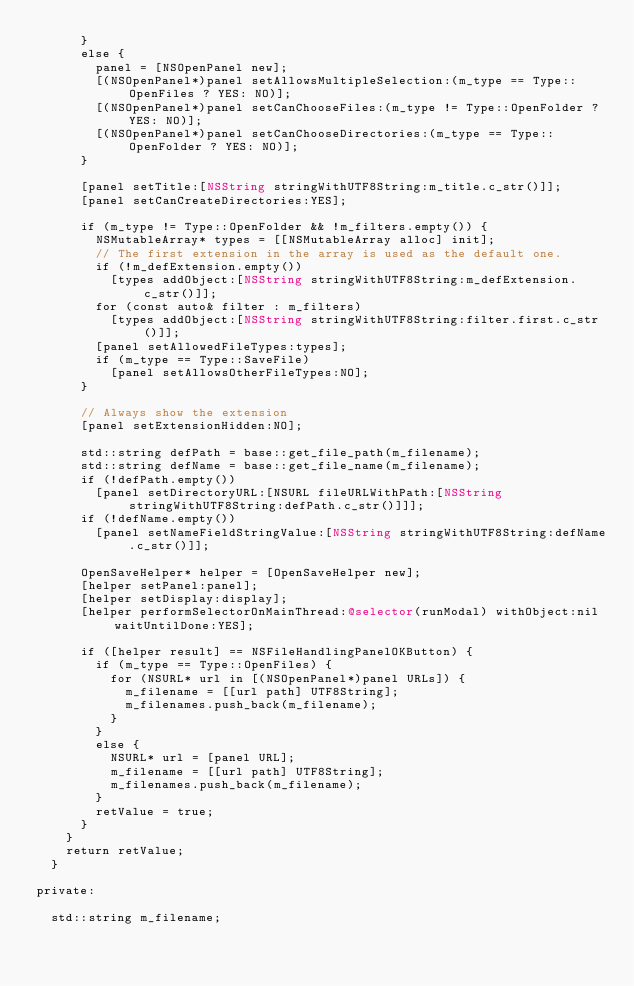Convert code to text. <code><loc_0><loc_0><loc_500><loc_500><_ObjectiveC_>      }
      else {
        panel = [NSOpenPanel new];
        [(NSOpenPanel*)panel setAllowsMultipleSelection:(m_type == Type::OpenFiles ? YES: NO)];
        [(NSOpenPanel*)panel setCanChooseFiles:(m_type != Type::OpenFolder ? YES: NO)];
        [(NSOpenPanel*)panel setCanChooseDirectories:(m_type == Type::OpenFolder ? YES: NO)];
      }

      [panel setTitle:[NSString stringWithUTF8String:m_title.c_str()]];
      [panel setCanCreateDirectories:YES];

      if (m_type != Type::OpenFolder && !m_filters.empty()) {
        NSMutableArray* types = [[NSMutableArray alloc] init];
        // The first extension in the array is used as the default one.
        if (!m_defExtension.empty())
          [types addObject:[NSString stringWithUTF8String:m_defExtension.c_str()]];
        for (const auto& filter : m_filters)
          [types addObject:[NSString stringWithUTF8String:filter.first.c_str()]];
        [panel setAllowedFileTypes:types];
        if (m_type == Type::SaveFile)
          [panel setAllowsOtherFileTypes:NO];
      }

      // Always show the extension
      [panel setExtensionHidden:NO];

      std::string defPath = base::get_file_path(m_filename);
      std::string defName = base::get_file_name(m_filename);
      if (!defPath.empty())
        [panel setDirectoryURL:[NSURL fileURLWithPath:[NSString stringWithUTF8String:defPath.c_str()]]];
      if (!defName.empty())
        [panel setNameFieldStringValue:[NSString stringWithUTF8String:defName.c_str()]];

      OpenSaveHelper* helper = [OpenSaveHelper new];
      [helper setPanel:panel];
      [helper setDisplay:display];
      [helper performSelectorOnMainThread:@selector(runModal) withObject:nil waitUntilDone:YES];

      if ([helper result] == NSFileHandlingPanelOKButton) {
        if (m_type == Type::OpenFiles) {
          for (NSURL* url in [(NSOpenPanel*)panel URLs]) {
            m_filename = [[url path] UTF8String];
            m_filenames.push_back(m_filename);
          }
        }
        else {
          NSURL* url = [panel URL];
          m_filename = [[url path] UTF8String];
          m_filenames.push_back(m_filename);
        }
        retValue = true;
      }
    }
    return retValue;
  }

private:

  std::string m_filename;</code> 